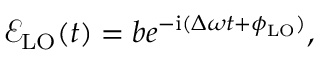Convert formula to latex. <formula><loc_0><loc_0><loc_500><loc_500>\mathcal { E } _ { L O } ( t ) = b e ^ { - { i } ( \Delta \omega t + \phi _ { L O } ) } ,</formula> 